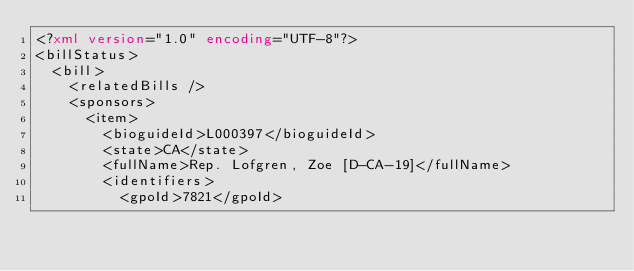Convert code to text. <code><loc_0><loc_0><loc_500><loc_500><_XML_><?xml version="1.0" encoding="UTF-8"?>
<billStatus>
  <bill>
    <relatedBills />
    <sponsors>
      <item>
        <bioguideId>L000397</bioguideId>
        <state>CA</state>
        <fullName>Rep. Lofgren, Zoe [D-CA-19]</fullName>
        <identifiers>
          <gpoId>7821</gpoId></code> 